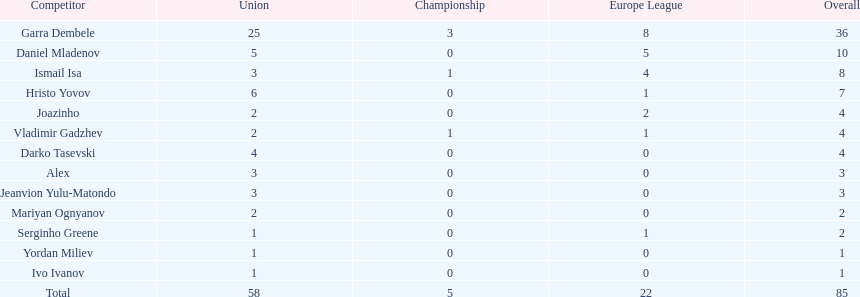What is the aggregate of the cup total and the europa league total? 27. 